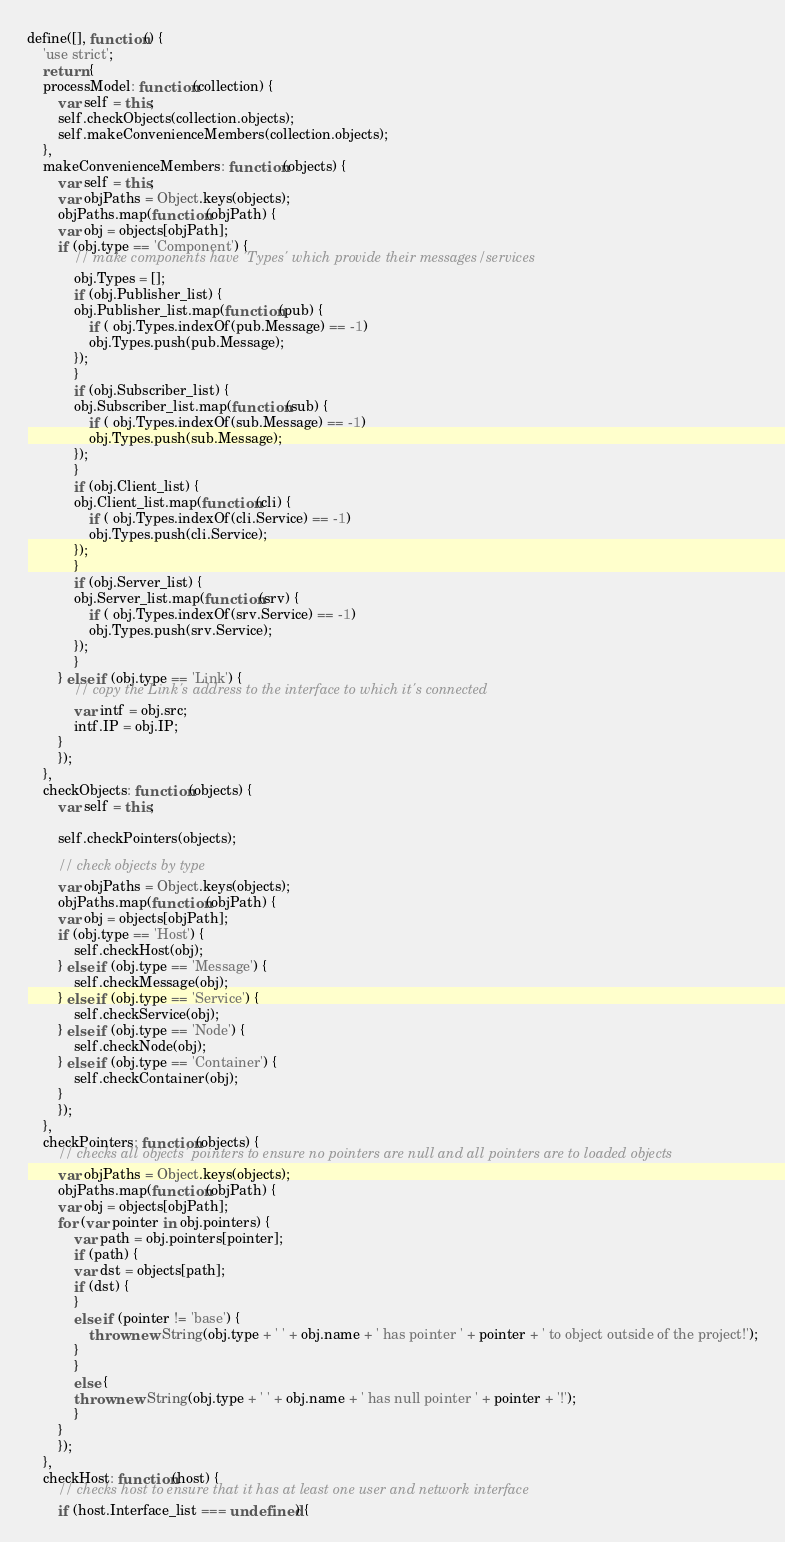Convert code to text. <code><loc_0><loc_0><loc_500><loc_500><_JavaScript_>

define([], function() {
    'use strict';
    return {
	processModel: function(collection) {
	    var self = this;
	    self.checkObjects(collection.objects);
	    self.makeConvenienceMembers(collection.objects);
	},
	makeConvenienceMembers: function(objects) {
	    var self = this;
	    var objPaths = Object.keys(objects);
	    objPaths.map(function(objPath) {
		var obj = objects[objPath];
		if (obj.type == 'Component') {
		    // make components have 'Types' which provide their messages/services
		    obj.Types = []; 
		    if (obj.Publisher_list) {
			obj.Publisher_list.map(function(pub) {
			    if ( obj.Types.indexOf(pub.Message) == -1)
				obj.Types.push(pub.Message);
			});
		    }
		    if (obj.Subscriber_list) {
			obj.Subscriber_list.map(function(sub) {
			    if ( obj.Types.indexOf(sub.Message) == -1)
				obj.Types.push(sub.Message);
			});
		    }
		    if (obj.Client_list) {
			obj.Client_list.map(function(cli) {
			    if ( obj.Types.indexOf(cli.Service) == -1)
				obj.Types.push(cli.Service);
			});
		    }
		    if (obj.Server_list) {
			obj.Server_list.map(function(srv) {
			    if ( obj.Types.indexOf(srv.Service) == -1)
				obj.Types.push(srv.Service);
			});
		    }
		} else if (obj.type == 'Link') {
		    // copy the Link's address to the interface to which it's connected
		    var intf = obj.src;
		    intf.IP = obj.IP;
		}
	    });
	},
	checkObjects: function(objects) {
	    var self = this;

	    self.checkPointers(objects);

	    // check objects by type
	    var objPaths = Object.keys(objects);
	    objPaths.map(function(objPath) {
		var obj = objects[objPath];
		if (obj.type == 'Host') {
		    self.checkHost(obj);
		} else if (obj.type == 'Message') {
		    self.checkMessage(obj);
		} else if (obj.type == 'Service') {
		    self.checkService(obj);
		} else if (obj.type == 'Node') {
		    self.checkNode(obj);
		} else if (obj.type == 'Container') {
		    self.checkContainer(obj);
		}
	    });
	},
	checkPointers: function(objects) {
	    // checks all objects' pointers to ensure no pointers are null and all pointers are to loaded objects
	    var objPaths = Object.keys(objects);
	    objPaths.map(function(objPath) {
		var obj = objects[objPath];
		for (var pointer in obj.pointers) {
		    var path = obj.pointers[pointer];
		    if (path) {
			var dst = objects[path];
			if (dst) {
			}
			else if (pointer != 'base') {
			    throw new String(obj.type + ' ' + obj.name + ' has pointer ' + pointer + ' to object outside of the project!');
			}
		    }
		    else {
			throw new String(obj.type + ' ' + obj.name + ' has null pointer ' + pointer + '!');
		    }
		}
	    });
	},
	checkHost: function(host) {
	    // checks host to ensure that it has at least one user and network interface
	    if (host.Interface_list === undefined) {</code> 